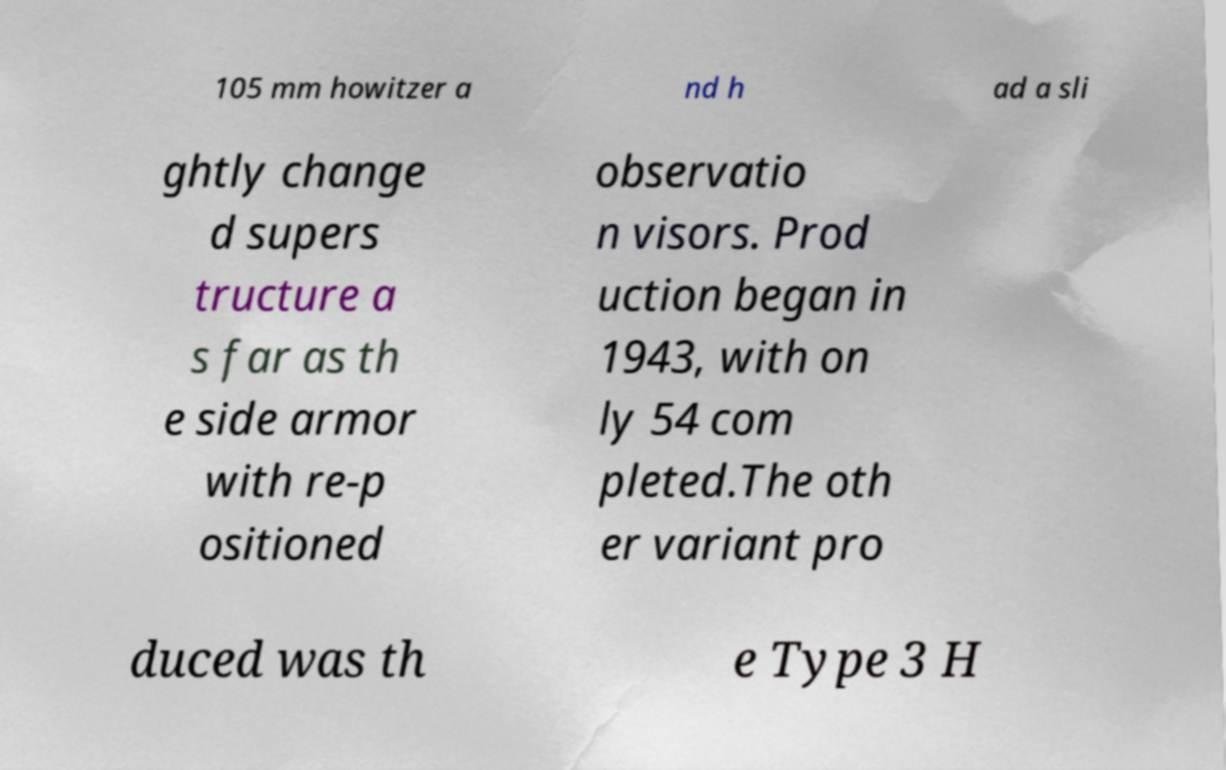Could you extract and type out the text from this image? 105 mm howitzer a nd h ad a sli ghtly change d supers tructure a s far as th e side armor with re-p ositioned observatio n visors. Prod uction began in 1943, with on ly 54 com pleted.The oth er variant pro duced was th e Type 3 H 